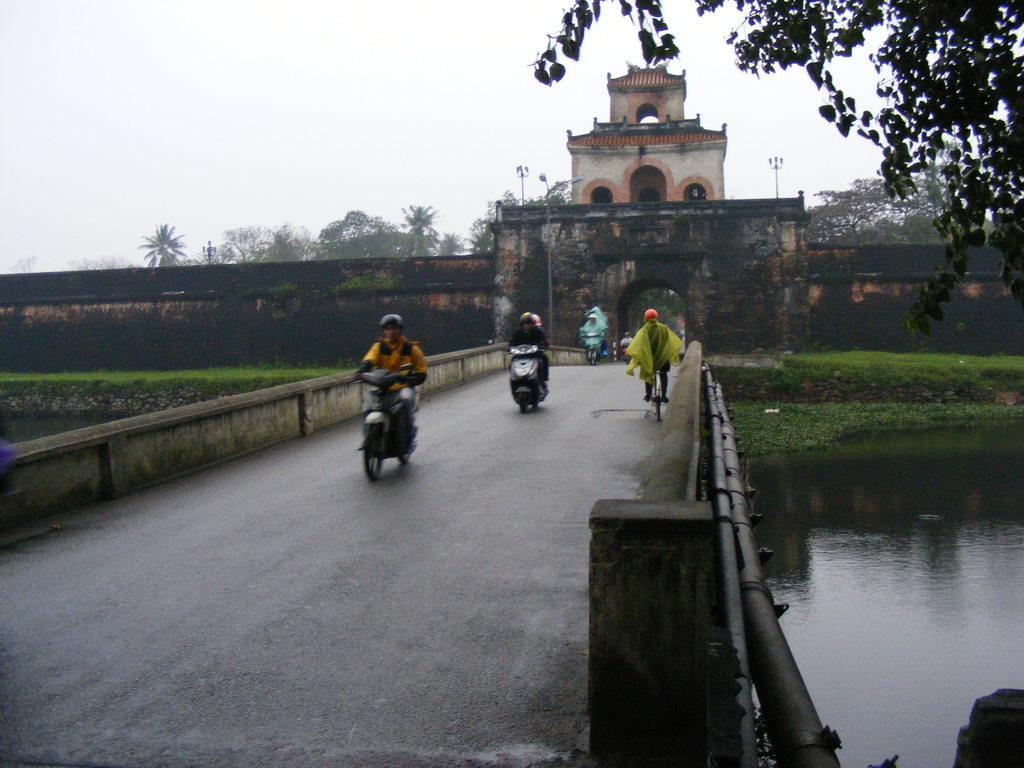What type of natural elements can be seen in the image? There are trees in the image. What type of structure is present in the image? There is an arch, a wall, a building, and a bridge in the image. What are the people in the image doing? There are people riding vehicles in the image. What is the color of the sky in the image? The sky appears to be white in color. What type of business is being conducted on the side of the bridge in the image? There is no indication of any business being conducted in the image, and the bridge does not have a side visible. 